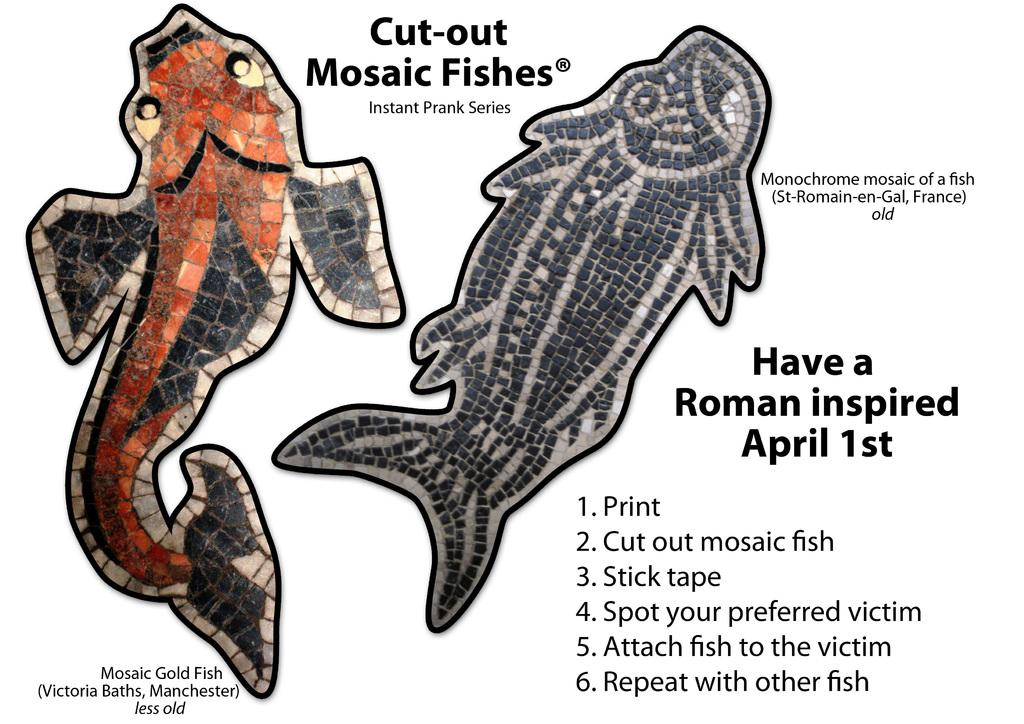What type of animals can be seen in the image? There are depictions of fishes in the image. What else is present on the image besides the fishes? There is text on the image. What is the name of the daughter mentioned in the image? There is no mention of a daughter in the image; it only contains depictions of fishes and text. 